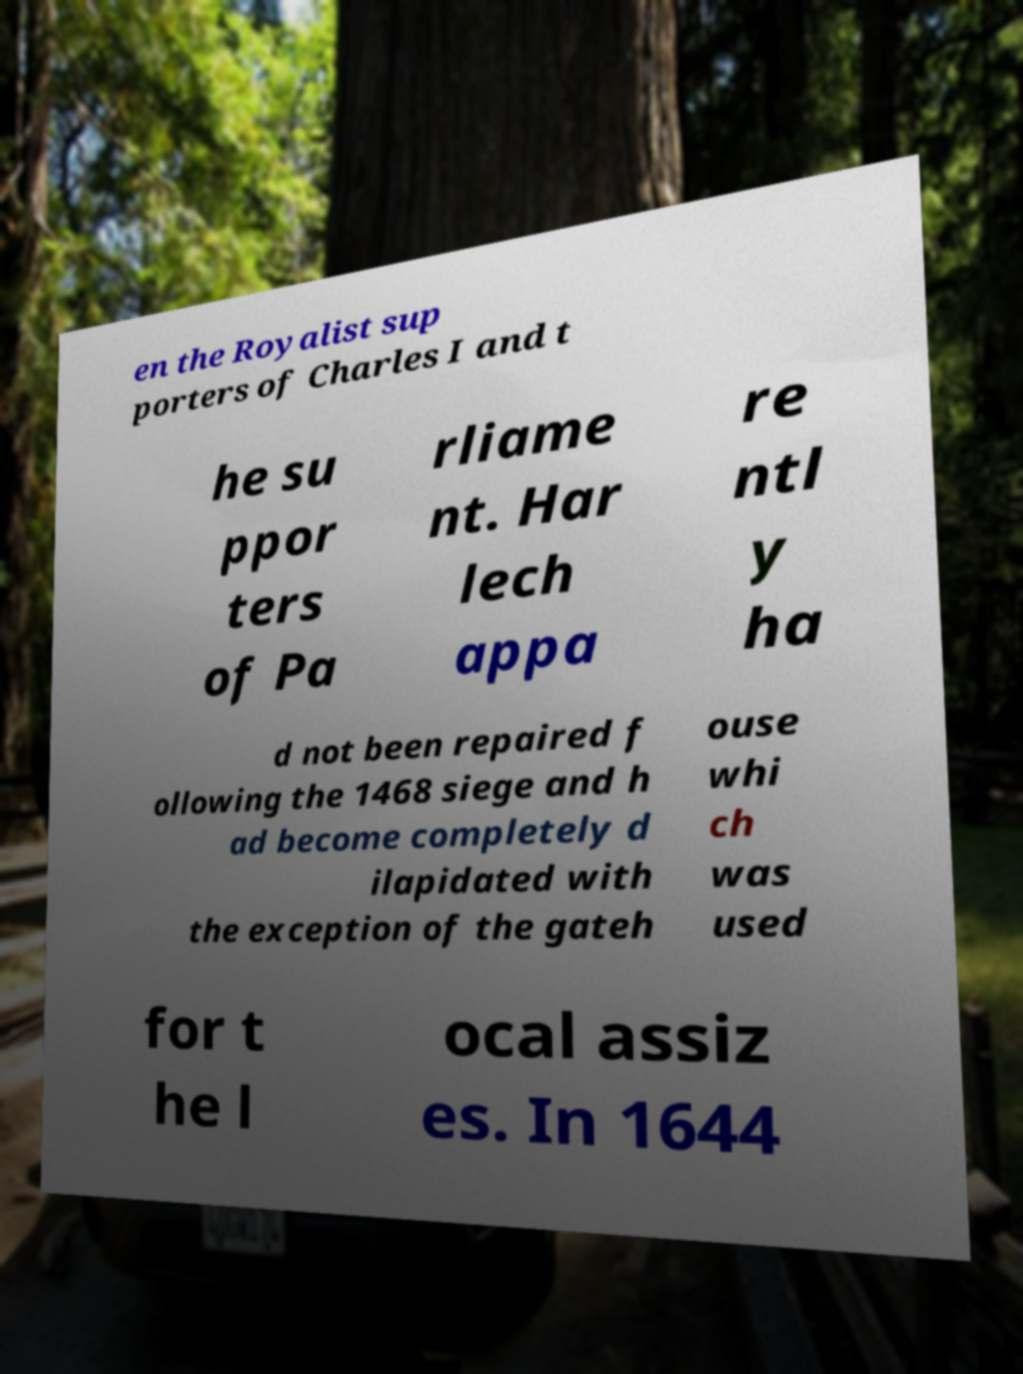Can you accurately transcribe the text from the provided image for me? en the Royalist sup porters of Charles I and t he su ppor ters of Pa rliame nt. Har lech appa re ntl y ha d not been repaired f ollowing the 1468 siege and h ad become completely d ilapidated with the exception of the gateh ouse whi ch was used for t he l ocal assiz es. In 1644 